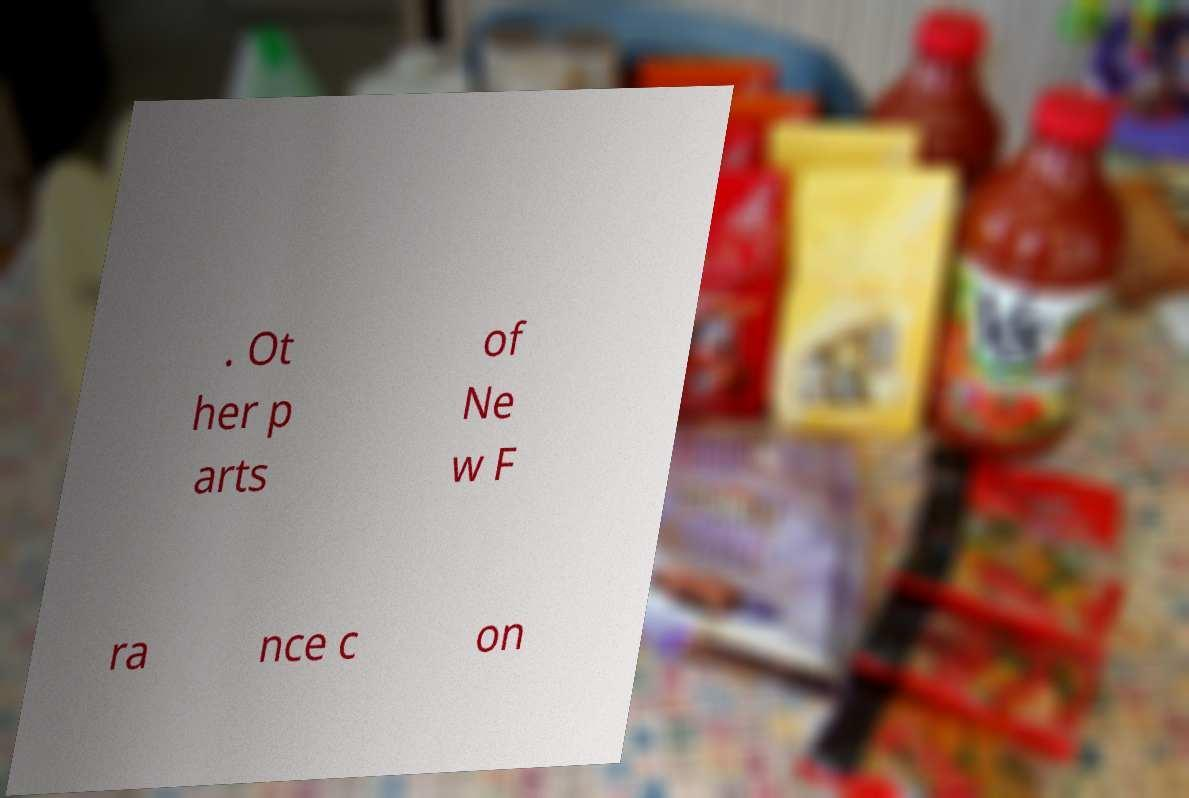Please read and relay the text visible in this image. What does it say? . Ot her p arts of Ne w F ra nce c on 